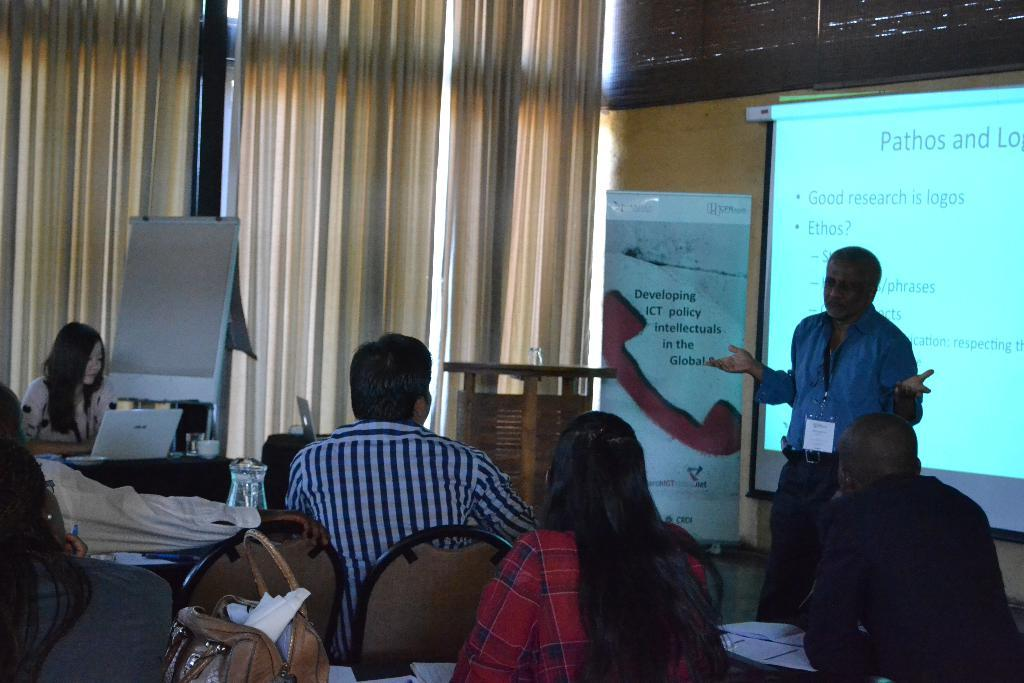What are the people in the image doing? The people in the image are sitting on chairs. What items can be seen near the people? There are bags, papers, tables, laptops, and a board in the image. What additional items are present in the image? There is a banner, a screen, and curtains in the image. Can you describe the man in the image? There is a man standing in the image. What other objects can be seen in the image? There are other objects in the image, but their specific details are not mentioned in the provided facts. What type of light is being used to illuminate the bags in the image? There is no specific information about the type of light in the image, and the bags are not the main focus of the image. 